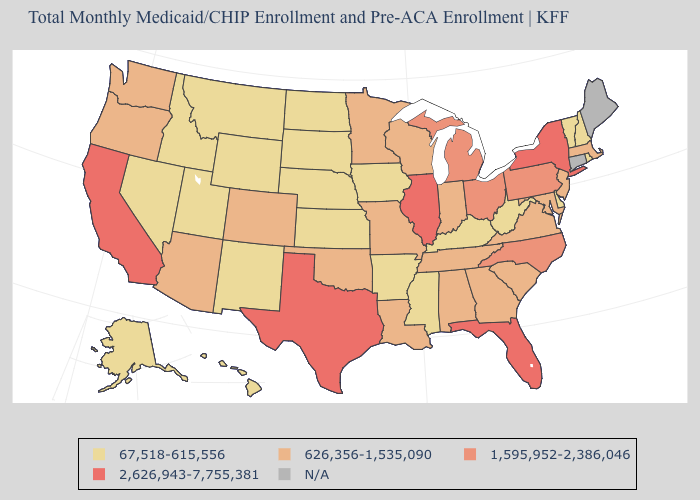What is the highest value in states that border Washington?
Answer briefly. 626,356-1,535,090. Does Indiana have the highest value in the MidWest?
Give a very brief answer. No. What is the value of Washington?
Concise answer only. 626,356-1,535,090. What is the value of Montana?
Short answer required. 67,518-615,556. Name the states that have a value in the range 2,626,943-7,755,381?
Answer briefly. California, Florida, Illinois, New York, Texas. What is the lowest value in the USA?
Keep it brief. 67,518-615,556. Name the states that have a value in the range 626,356-1,535,090?
Short answer required. Alabama, Arizona, Colorado, Georgia, Indiana, Louisiana, Maryland, Massachusetts, Minnesota, Missouri, New Jersey, Oklahoma, Oregon, South Carolina, Tennessee, Virginia, Washington, Wisconsin. Name the states that have a value in the range 67,518-615,556?
Short answer required. Alaska, Arkansas, Delaware, Hawaii, Idaho, Iowa, Kansas, Kentucky, Mississippi, Montana, Nebraska, Nevada, New Hampshire, New Mexico, North Dakota, Rhode Island, South Dakota, Utah, Vermont, West Virginia, Wyoming. Name the states that have a value in the range 2,626,943-7,755,381?
Give a very brief answer. California, Florida, Illinois, New York, Texas. How many symbols are there in the legend?
Be succinct. 5. Which states have the highest value in the USA?
Short answer required. California, Florida, Illinois, New York, Texas. Among the states that border Minnesota , which have the lowest value?
Be succinct. Iowa, North Dakota, South Dakota. What is the value of Indiana?
Answer briefly. 626,356-1,535,090. Which states have the highest value in the USA?
Keep it brief. California, Florida, Illinois, New York, Texas. What is the value of West Virginia?
Concise answer only. 67,518-615,556. 